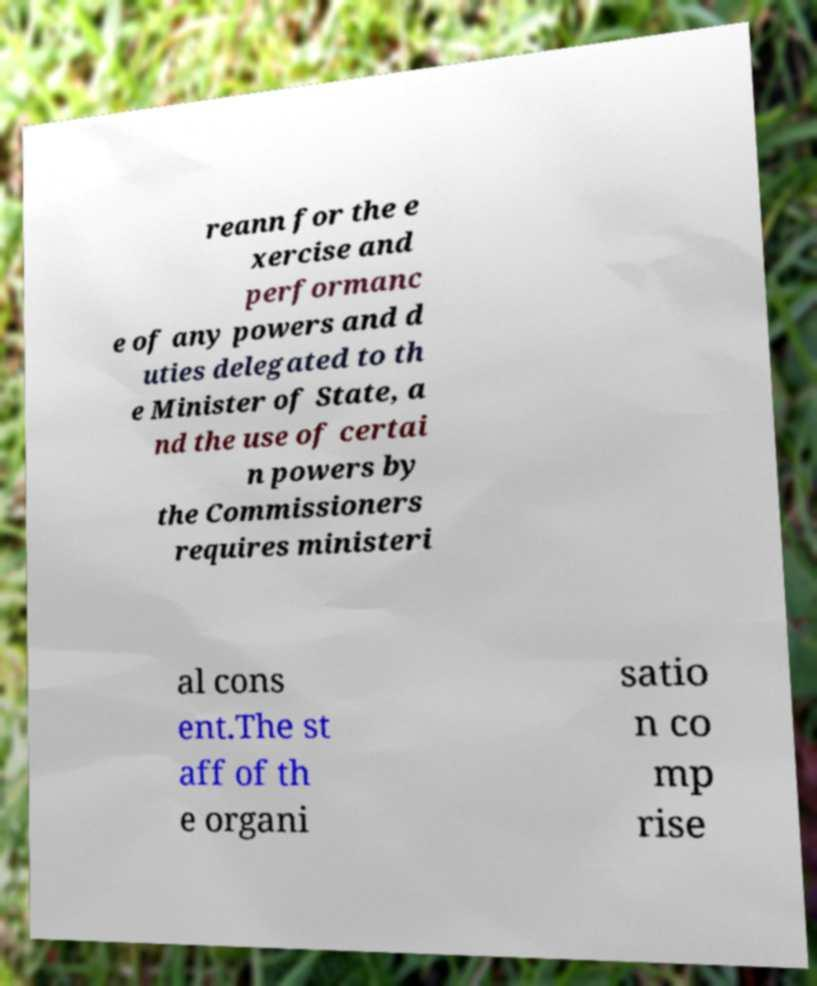Can you accurately transcribe the text from the provided image for me? reann for the e xercise and performanc e of any powers and d uties delegated to th e Minister of State, a nd the use of certai n powers by the Commissioners requires ministeri al cons ent.The st aff of th e organi satio n co mp rise 